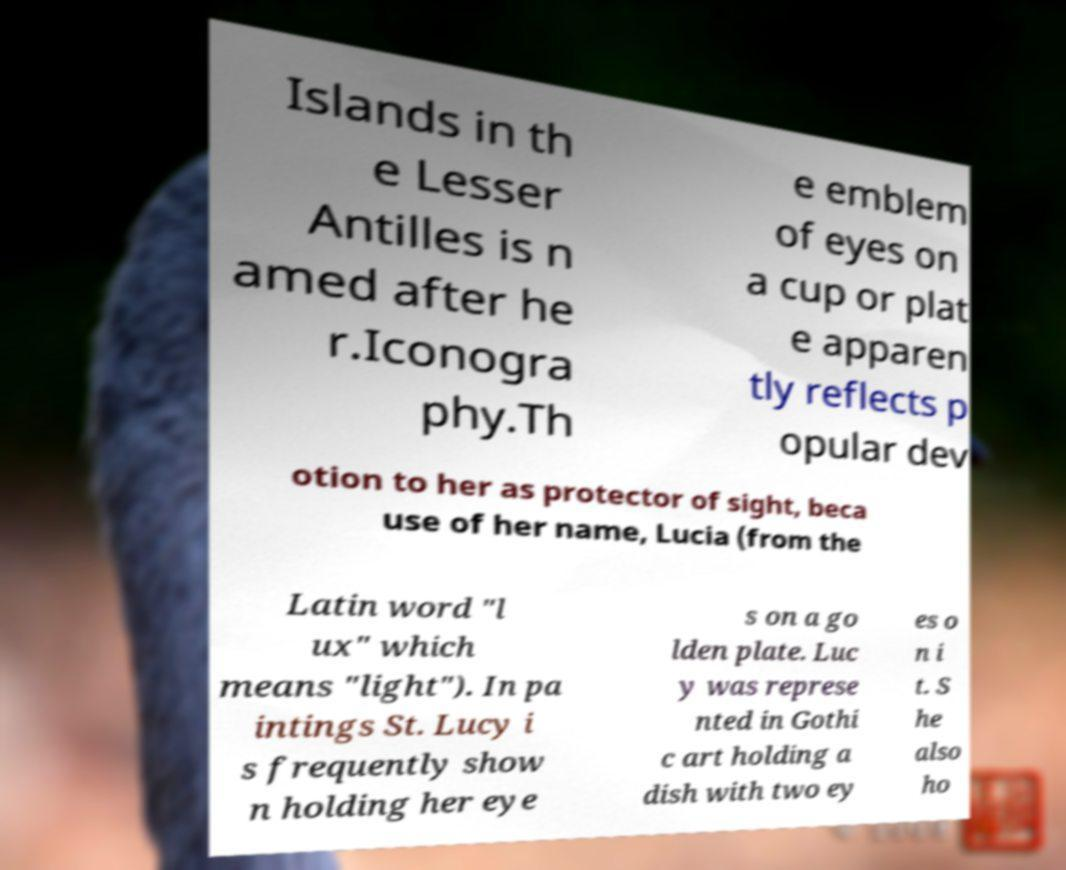Could you assist in decoding the text presented in this image and type it out clearly? Islands in th e Lesser Antilles is n amed after he r.Iconogra phy.Th e emblem of eyes on a cup or plat e apparen tly reflects p opular dev otion to her as protector of sight, beca use of her name, Lucia (from the Latin word "l ux" which means "light"). In pa intings St. Lucy i s frequently show n holding her eye s on a go lden plate. Luc y was represe nted in Gothi c art holding a dish with two ey es o n i t. S he also ho 